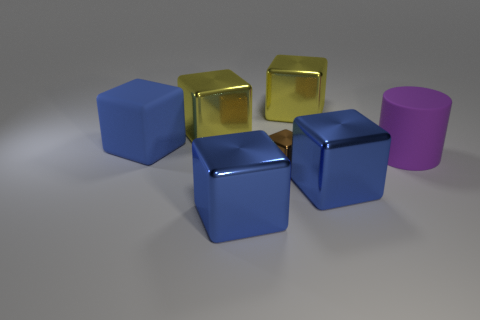Are there an equal number of brown objects and metallic cubes?
Your response must be concise. No. Do the matte object on the left side of the purple matte object and the rubber object in front of the matte block have the same shape?
Provide a short and direct response. No. Is there a large gray block made of the same material as the large cylinder?
Offer a very short reply. No. What number of blue objects are either large rubber cylinders or small shiny objects?
Provide a succinct answer. 0. There is a cube that is both in front of the large blue rubber thing and on the right side of the brown metal cube; how big is it?
Offer a very short reply. Large. Is the number of big yellow shiny things on the right side of the tiny cube greater than the number of small brown cubes?
Provide a short and direct response. No. What number of cylinders are either large objects or tiny metallic objects?
Ensure brevity in your answer.  1. What is the shape of the large thing that is behind the small thing and in front of the large rubber block?
Keep it short and to the point. Cylinder. Is the number of purple cylinders to the right of the small brown cube the same as the number of things that are in front of the large cylinder?
Your response must be concise. No. What number of things are either small brown shiny cylinders or brown shiny cubes?
Offer a very short reply. 1. 